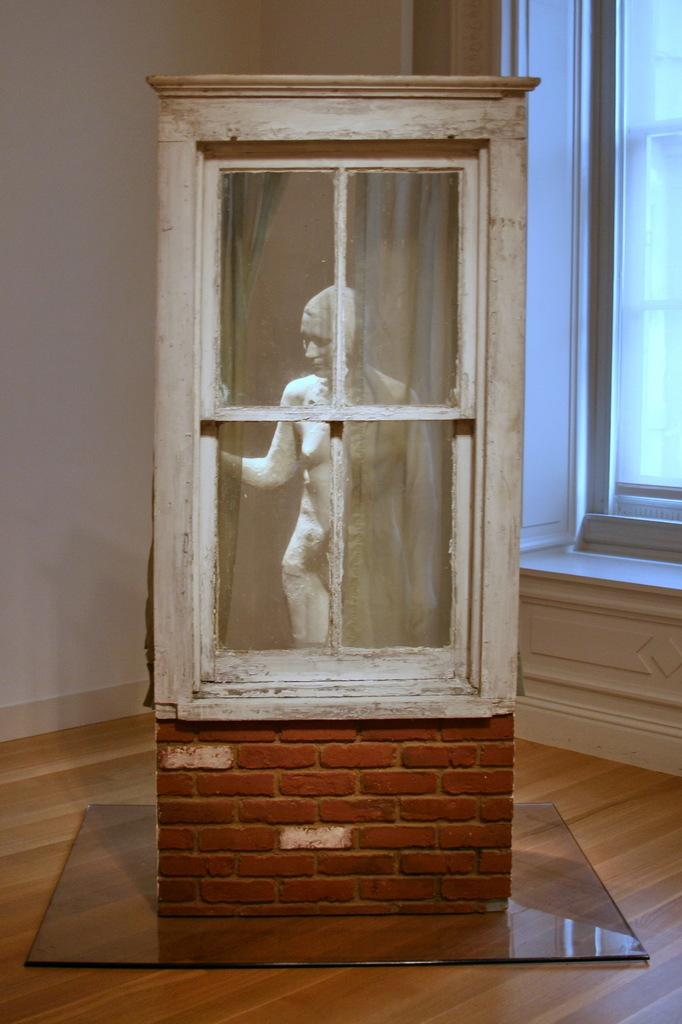What type of flooring is visible in the image? There is a wooden floor in the image. What object is placed on the wooden floor? There is a box on the wooden floor. What is inside the box? There is a sculpture inside the box. What surrounds the box in the image? There are walls surrounding the box. Can you describe the window in the image? There is a window in one of the walls. What is the chance of finding a receipt inside the sculpture? There is no mention of a receipt in the image, so it cannot be determined if there is a chance of finding one inside the sculpture. 